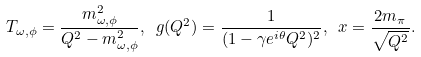Convert formula to latex. <formula><loc_0><loc_0><loc_500><loc_500>T _ { \omega , \phi } = \frac { m ^ { 2 } _ { \omega , \phi } } { Q ^ { 2 } - m ^ { 2 } _ { \omega , \phi } } , \ g ( Q ^ { 2 } ) = \frac { 1 } { ( 1 - \gamma e ^ { i \theta } Q ^ { 2 } ) ^ { 2 } } , \ x = \frac { 2 m _ { \pi } } { \sqrt { Q ^ { 2 } } } .</formula> 